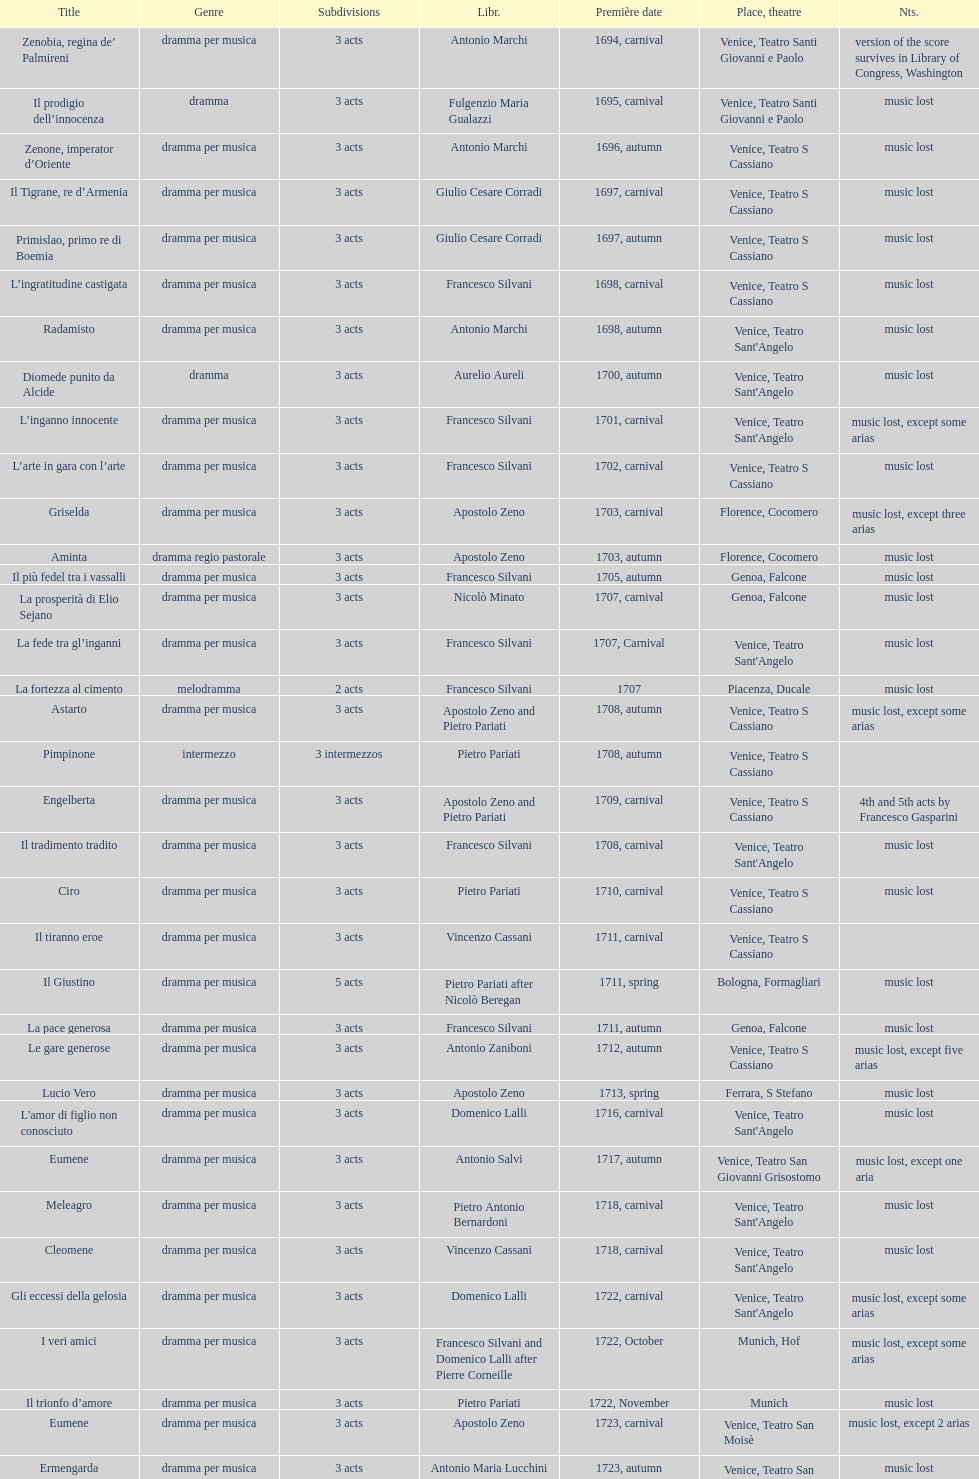L'inganno innocente premiered in 1701. what was the previous title released? Diomede punito da Alcide. Parse the full table. {'header': ['Title', 'Genre', 'Subdivisions', 'Libr.', 'Première date', 'Place, theatre', 'Nts.'], 'rows': [['Zenobia, regina de’ Palmireni', 'dramma per musica', '3 acts', 'Antonio Marchi', '1694, carnival', 'Venice, Teatro Santi Giovanni e Paolo', 'version of the score survives in Library of Congress, Washington'], ['Il prodigio dell’innocenza', 'dramma', '3 acts', 'Fulgenzio Maria Gualazzi', '1695, carnival', 'Venice, Teatro Santi Giovanni e Paolo', 'music lost'], ['Zenone, imperator d’Oriente', 'dramma per musica', '3 acts', 'Antonio Marchi', '1696, autumn', 'Venice, Teatro S Cassiano', 'music lost'], ['Il Tigrane, re d’Armenia', 'dramma per musica', '3 acts', 'Giulio Cesare Corradi', '1697, carnival', 'Venice, Teatro S Cassiano', 'music lost'], ['Primislao, primo re di Boemia', 'dramma per musica', '3 acts', 'Giulio Cesare Corradi', '1697, autumn', 'Venice, Teatro S Cassiano', 'music lost'], ['L’ingratitudine castigata', 'dramma per musica', '3 acts', 'Francesco Silvani', '1698, carnival', 'Venice, Teatro S Cassiano', 'music lost'], ['Radamisto', 'dramma per musica', '3 acts', 'Antonio Marchi', '1698, autumn', "Venice, Teatro Sant'Angelo", 'music lost'], ['Diomede punito da Alcide', 'dramma', '3 acts', 'Aurelio Aureli', '1700, autumn', "Venice, Teatro Sant'Angelo", 'music lost'], ['L’inganno innocente', 'dramma per musica', '3 acts', 'Francesco Silvani', '1701, carnival', "Venice, Teatro Sant'Angelo", 'music lost, except some arias'], ['L’arte in gara con l’arte', 'dramma per musica', '3 acts', 'Francesco Silvani', '1702, carnival', 'Venice, Teatro S Cassiano', 'music lost'], ['Griselda', 'dramma per musica', '3 acts', 'Apostolo Zeno', '1703, carnival', 'Florence, Cocomero', 'music lost, except three arias'], ['Aminta', 'dramma regio pastorale', '3 acts', 'Apostolo Zeno', '1703, autumn', 'Florence, Cocomero', 'music lost'], ['Il più fedel tra i vassalli', 'dramma per musica', '3 acts', 'Francesco Silvani', '1705, autumn', 'Genoa, Falcone', 'music lost'], ['La prosperità di Elio Sejano', 'dramma per musica', '3 acts', 'Nicolò Minato', '1707, carnival', 'Genoa, Falcone', 'music lost'], ['La fede tra gl’inganni', 'dramma per musica', '3 acts', 'Francesco Silvani', '1707, Carnival', "Venice, Teatro Sant'Angelo", 'music lost'], ['La fortezza al cimento', 'melodramma', '2 acts', 'Francesco Silvani', '1707', 'Piacenza, Ducale', 'music lost'], ['Astarto', 'dramma per musica', '3 acts', 'Apostolo Zeno and Pietro Pariati', '1708, autumn', 'Venice, Teatro S Cassiano', 'music lost, except some arias'], ['Pimpinone', 'intermezzo', '3 intermezzos', 'Pietro Pariati', '1708, autumn', 'Venice, Teatro S Cassiano', ''], ['Engelberta', 'dramma per musica', '3 acts', 'Apostolo Zeno and Pietro Pariati', '1709, carnival', 'Venice, Teatro S Cassiano', '4th and 5th acts by Francesco Gasparini'], ['Il tradimento tradito', 'dramma per musica', '3 acts', 'Francesco Silvani', '1708, carnival', "Venice, Teatro Sant'Angelo", 'music lost'], ['Ciro', 'dramma per musica', '3 acts', 'Pietro Pariati', '1710, carnival', 'Venice, Teatro S Cassiano', 'music lost'], ['Il tiranno eroe', 'dramma per musica', '3 acts', 'Vincenzo Cassani', '1711, carnival', 'Venice, Teatro S Cassiano', ''], ['Il Giustino', 'dramma per musica', '5 acts', 'Pietro Pariati after Nicolò Beregan', '1711, spring', 'Bologna, Formagliari', 'music lost'], ['La pace generosa', 'dramma per musica', '3 acts', 'Francesco Silvani', '1711, autumn', 'Genoa, Falcone', 'music lost'], ['Le gare generose', 'dramma per musica', '3 acts', 'Antonio Zaniboni', '1712, autumn', 'Venice, Teatro S Cassiano', 'music lost, except five arias'], ['Lucio Vero', 'dramma per musica', '3 acts', 'Apostolo Zeno', '1713, spring', 'Ferrara, S Stefano', 'music lost'], ["L'amor di figlio non conosciuto", 'dramma per musica', '3 acts', 'Domenico Lalli', '1716, carnival', "Venice, Teatro Sant'Angelo", 'music lost'], ['Eumene', 'dramma per musica', '3 acts', 'Antonio Salvi', '1717, autumn', 'Venice, Teatro San Giovanni Grisostomo', 'music lost, except one aria'], ['Meleagro', 'dramma per musica', '3 acts', 'Pietro Antonio Bernardoni', '1718, carnival', "Venice, Teatro Sant'Angelo", 'music lost'], ['Cleomene', 'dramma per musica', '3 acts', 'Vincenzo Cassani', '1718, carnival', "Venice, Teatro Sant'Angelo", 'music lost'], ['Gli eccessi della gelosia', 'dramma per musica', '3 acts', 'Domenico Lalli', '1722, carnival', "Venice, Teatro Sant'Angelo", 'music lost, except some arias'], ['I veri amici', 'dramma per musica', '3 acts', 'Francesco Silvani and Domenico Lalli after Pierre Corneille', '1722, October', 'Munich, Hof', 'music lost, except some arias'], ['Il trionfo d’amore', 'dramma per musica', '3 acts', 'Pietro Pariati', '1722, November', 'Munich', 'music lost'], ['Eumene', 'dramma per musica', '3 acts', 'Apostolo Zeno', '1723, carnival', 'Venice, Teatro San Moisè', 'music lost, except 2 arias'], ['Ermengarda', 'dramma per musica', '3 acts', 'Antonio Maria Lucchini', '1723, autumn', 'Venice, Teatro San Moisè', 'music lost'], ['Antigono, tutore di Filippo, re di Macedonia', 'tragedia', '5 acts', 'Giovanni Piazzon', '1724, carnival', 'Venice, Teatro San Moisè', '5th act by Giovanni Porta, music lost'], ['Scipione nelle Spagne', 'dramma per musica', '3 acts', 'Apostolo Zeno', '1724, Ascension', 'Venice, Teatro San Samuele', 'music lost'], ['Laodice', 'dramma per musica', '3 acts', 'Angelo Schietti', '1724, autumn', 'Venice, Teatro San Moisè', 'music lost, except 2 arias'], ['Didone abbandonata', 'tragedia', '3 acts', 'Metastasio', '1725, carnival', 'Venice, Teatro S Cassiano', 'music lost'], ["L'impresario delle Isole Canarie", 'intermezzo', '2 acts', 'Metastasio', '1725, carnival', 'Venice, Teatro S Cassiano', 'music lost'], ['Alcina delusa da Ruggero', 'dramma per musica', '3 acts', 'Antonio Marchi', '1725, autumn', 'Venice, Teatro S Cassiano', 'music lost'], ['I rivali generosi', 'dramma per musica', '3 acts', 'Apostolo Zeno', '1725', 'Brescia, Nuovo', ''], ['La Statira', 'dramma per musica', '3 acts', 'Apostolo Zeno and Pietro Pariati', '1726, Carnival', 'Rome, Teatro Capranica', ''], ['Malsazio e Fiammetta', 'intermezzo', '', '', '1726, Carnival', 'Rome, Teatro Capranica', ''], ['Il trionfo di Armida', 'dramma per musica', '3 acts', 'Girolamo Colatelli after Torquato Tasso', '1726, autumn', 'Venice, Teatro San Moisè', 'music lost'], ['L’incostanza schernita', 'dramma comico-pastorale', '3 acts', 'Vincenzo Cassani', '1727, Ascension', 'Venice, Teatro San Samuele', 'music lost, except some arias'], ['Le due rivali in amore', 'dramma per musica', '3 acts', 'Aurelio Aureli', '1728, autumn', 'Venice, Teatro San Moisè', 'music lost'], ['Il Satrapone', 'intermezzo', '', 'Salvi', '1729', 'Parma, Omodeo', ''], ['Li stratagemmi amorosi', 'dramma per musica', '3 acts', 'F Passerini', '1730, carnival', 'Venice, Teatro San Moisè', 'music lost'], ['Elenia', 'dramma per musica', '3 acts', 'Luisa Bergalli', '1730, carnival', "Venice, Teatro Sant'Angelo", 'music lost'], ['Merope', 'dramma', '3 acts', 'Apostolo Zeno', '1731, autumn', 'Prague, Sporck Theater', 'mostly by Albinoni, music lost'], ['Il più infedel tra gli amanti', 'dramma per musica', '3 acts', 'Angelo Schietti', '1731, autumn', 'Treviso, Dolphin', 'music lost'], ['Ardelinda', 'dramma', '3 acts', 'Bartolomeo Vitturi', '1732, autumn', "Venice, Teatro Sant'Angelo", 'music lost, except five arias'], ['Candalide', 'dramma per musica', '3 acts', 'Bartolomeo Vitturi', '1734, carnival', "Venice, Teatro Sant'Angelo", 'music lost'], ['Artamene', 'dramma per musica', '3 acts', 'Bartolomeo Vitturi', '1741, carnival', "Venice, Teatro Sant'Angelo", 'music lost']]} 